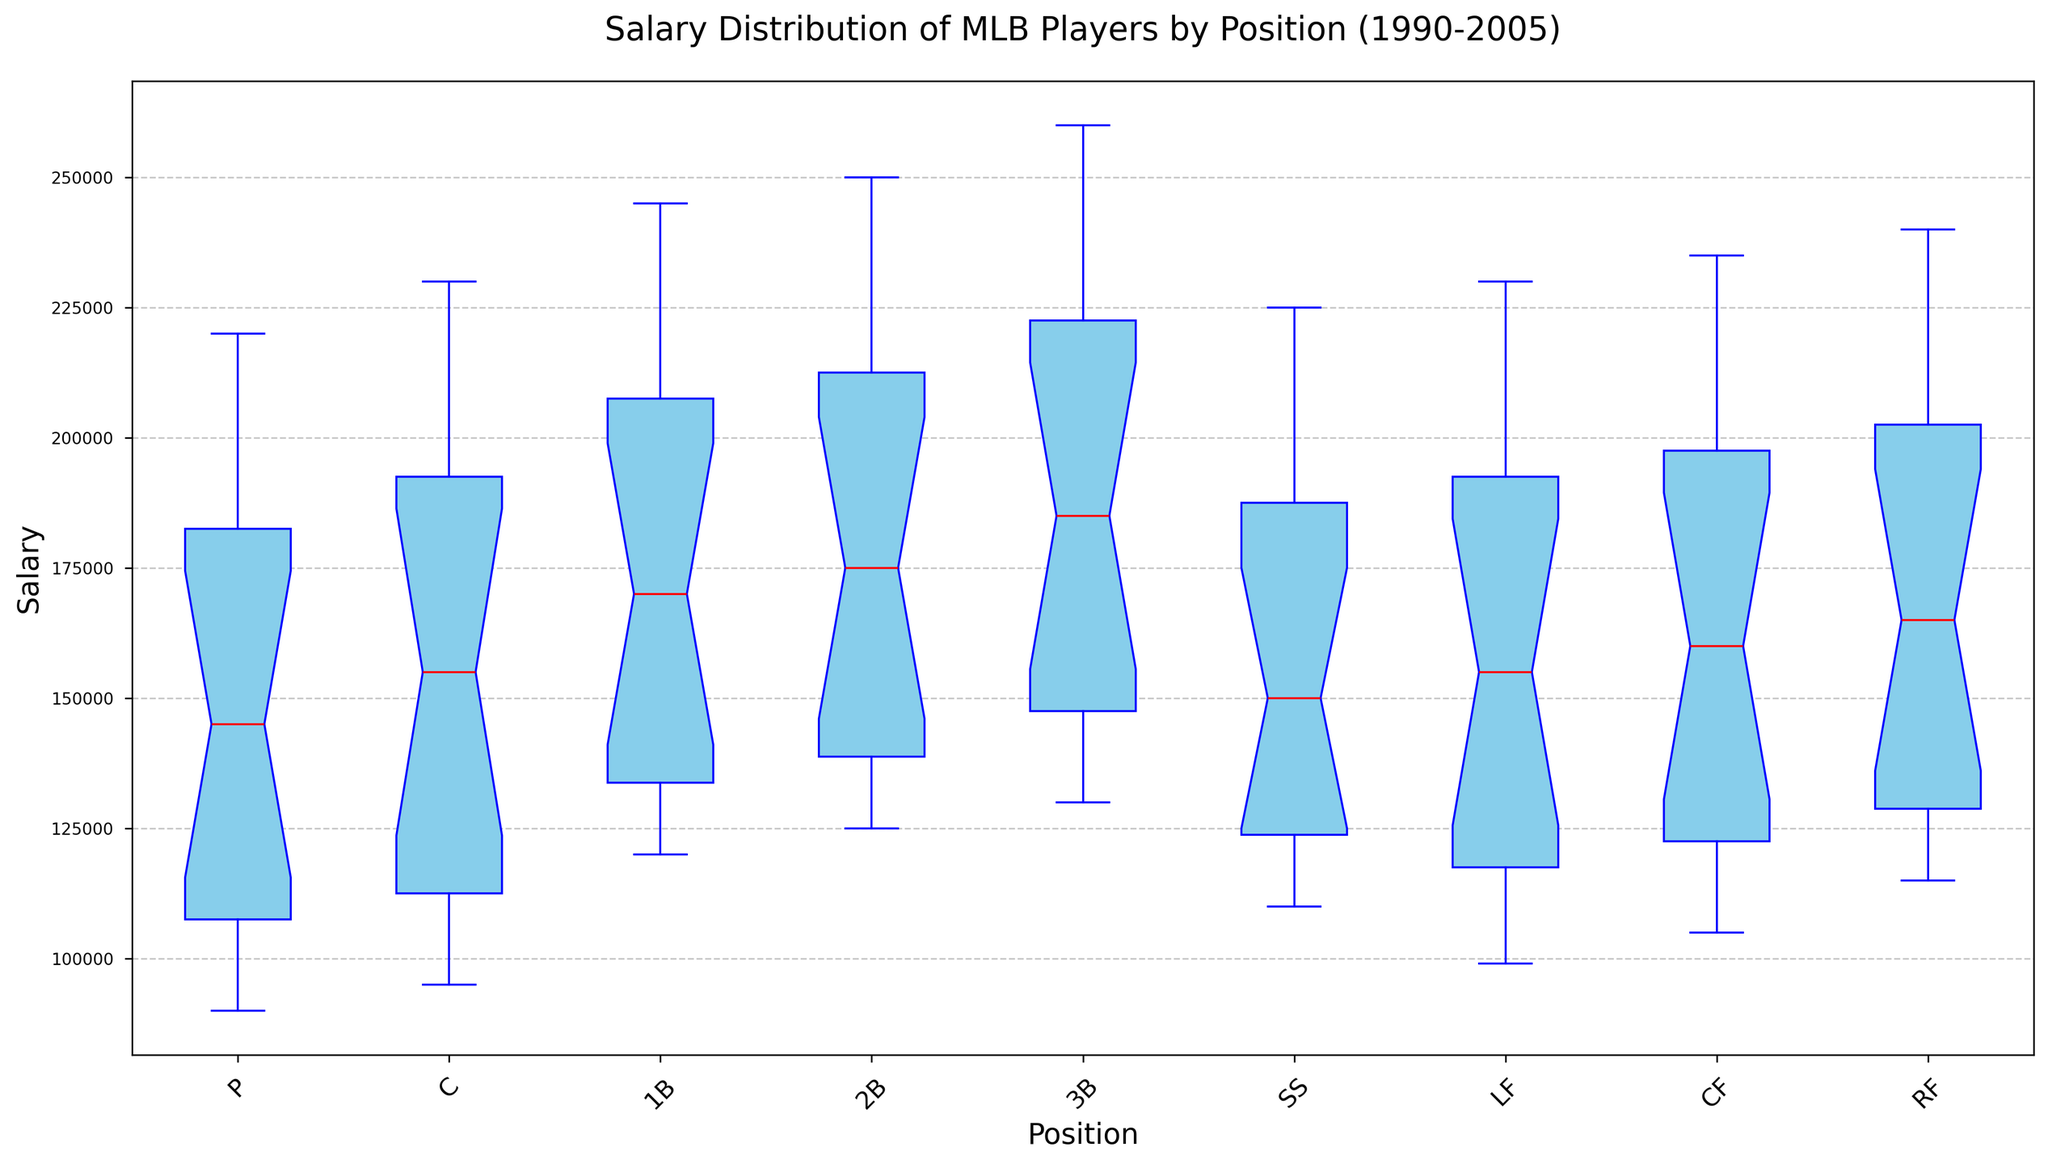What is the median salary for the Catcher (C) position? Locate the "C" category on the x-axis and find the red line inside the corresponding box plot, which represents the median salary.
Answer: 160000 Which position has the highest median salary and what is it? Identify the position with the highest red line inside the box plot. This is the position with the highest median salary.
Answer: 3B, 210000 How does the salary distribution for Pitchers (P) compare to that for Right Fielders (RF)? Observe the spread of the box plots for the "P" and "RF" categories. Look at the box height (interquartile range), whiskers (range), and median (red line). Compare these visual aspects to understand the distribution differences.
Answer: Pitchers have a lower distribution with a smaller range Which two positions have the closest median salaries and what are those medians? Find any two positions whose red lines (medians) are at very close or the same height in their respective box plots.
Answer: CF and RF, both around 185000 Are there any outliers noticeable in the plot? If so, for which position(s)? Look for any individual points (marked as 'o') outside the whiskers of the box plots which indicate outliers.
Answer: Not noticeable What's the interquartile range (IQR) for Second Basemen (2B)? Identify the top (75th percentile) and bottom (25th percentile) of the box for the "2B" category. Subtract the 25th percentile value from the 75th percentile value to get the IQR.
Answer: Approximately 50000 Is the median salary of Shortstops (SS) greater than that of Center Fielders (CF)? Compare the height of the red line in the SS box plot with that of the CF box plot.
Answer: Yes What can you infer about the salary progression over time for all positions? Generally, the height and range of the box plots suggest an increasing trend in median and range of salaries over the years. Compare the visual trends from 1990 to 2005.
Answer: Salaries have generally increased over time Which position has the most consistent (least variable) salary over the years? Look for the smallest box and shortest whiskers, indicating less variation in the salaries for that position.
Answer: Catcher (C) Between which years did the salary for First Basemen (1B) see the most significant increase in the median salary? Observe the positions of the red lines over different years for "1B" and identify where the largest jump occurs.
Answer: Around 1995-1996 